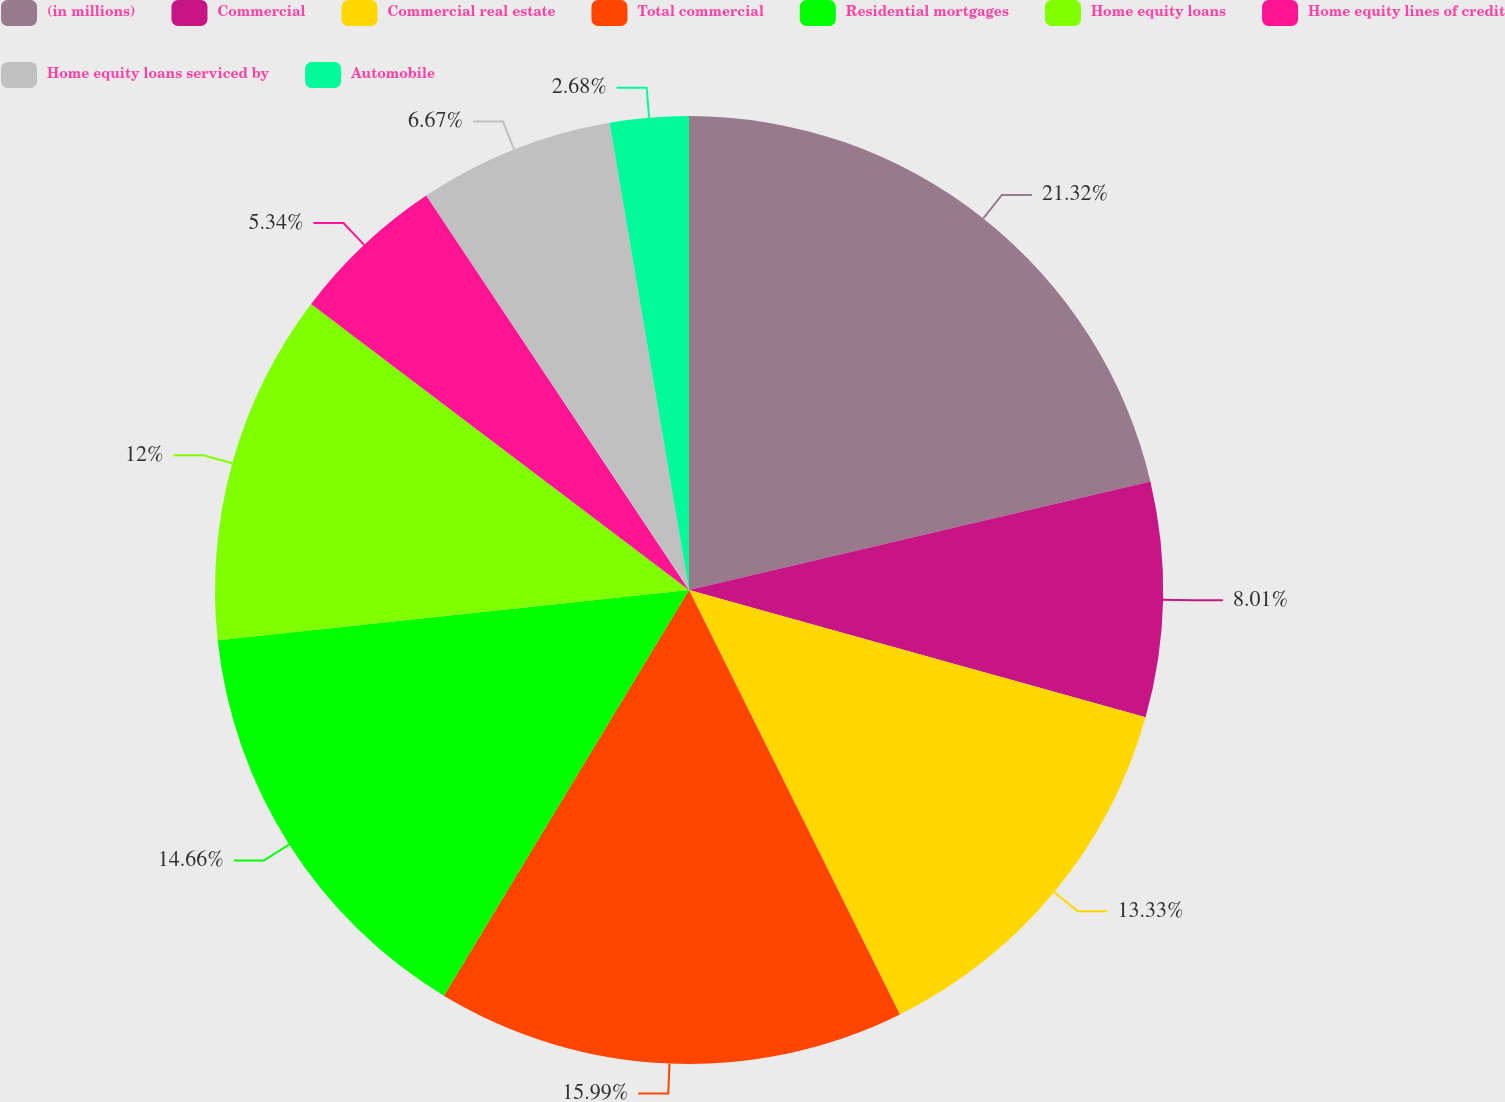Convert chart to OTSL. <chart><loc_0><loc_0><loc_500><loc_500><pie_chart><fcel>(in millions)<fcel>Commercial<fcel>Commercial real estate<fcel>Total commercial<fcel>Residential mortgages<fcel>Home equity loans<fcel>Home equity lines of credit<fcel>Home equity loans serviced by<fcel>Automobile<nl><fcel>21.32%<fcel>8.01%<fcel>13.33%<fcel>15.99%<fcel>14.66%<fcel>12.0%<fcel>5.34%<fcel>6.67%<fcel>2.68%<nl></chart> 